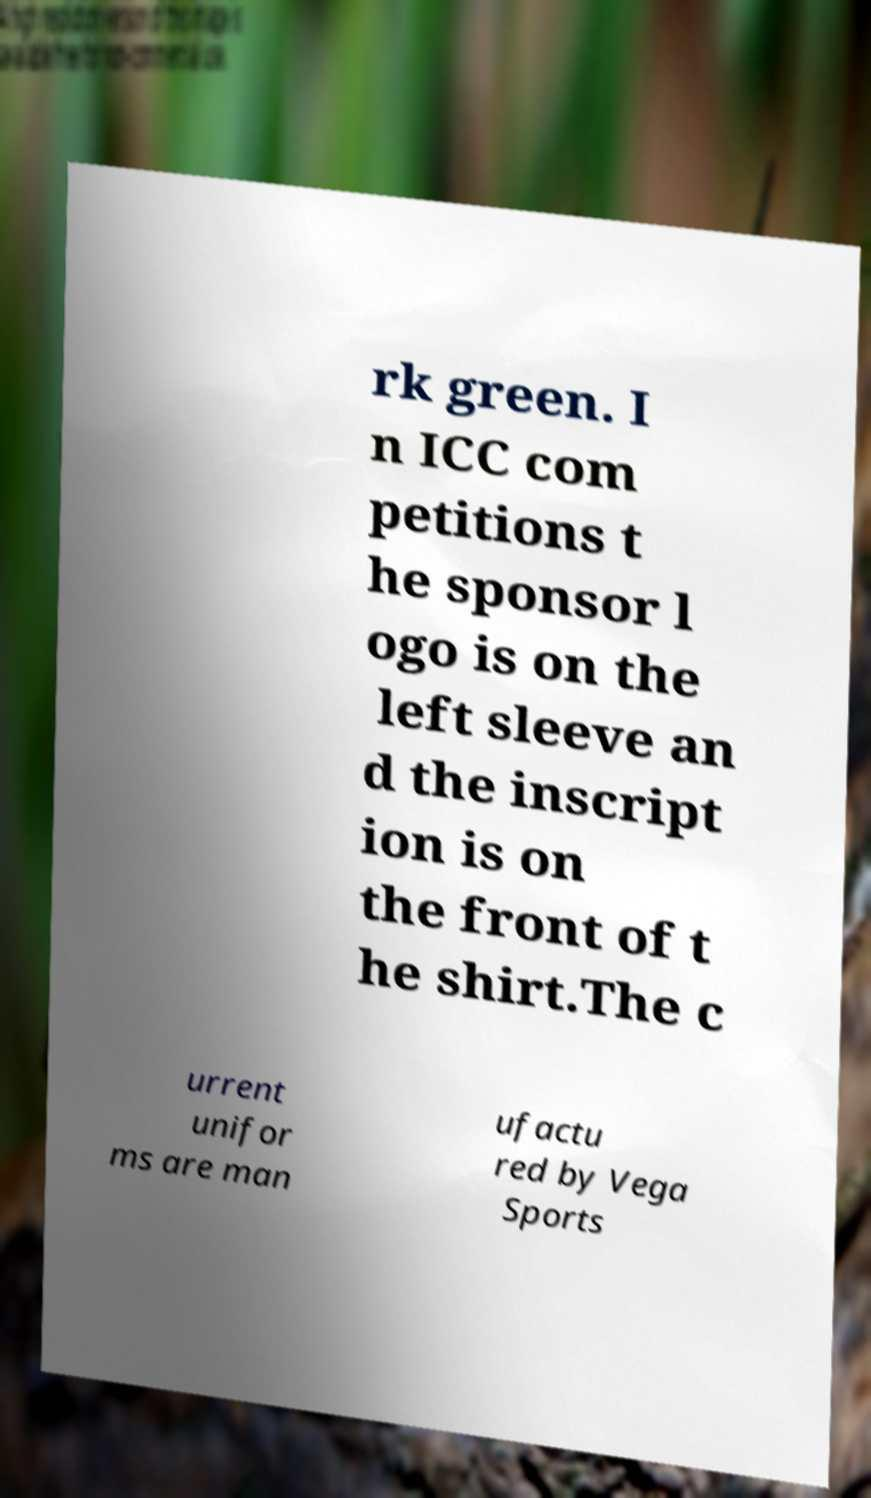Can you accurately transcribe the text from the provided image for me? rk green. I n ICC com petitions t he sponsor l ogo is on the left sleeve an d the inscript ion is on the front of t he shirt.The c urrent unifor ms are man ufactu red by Vega Sports 